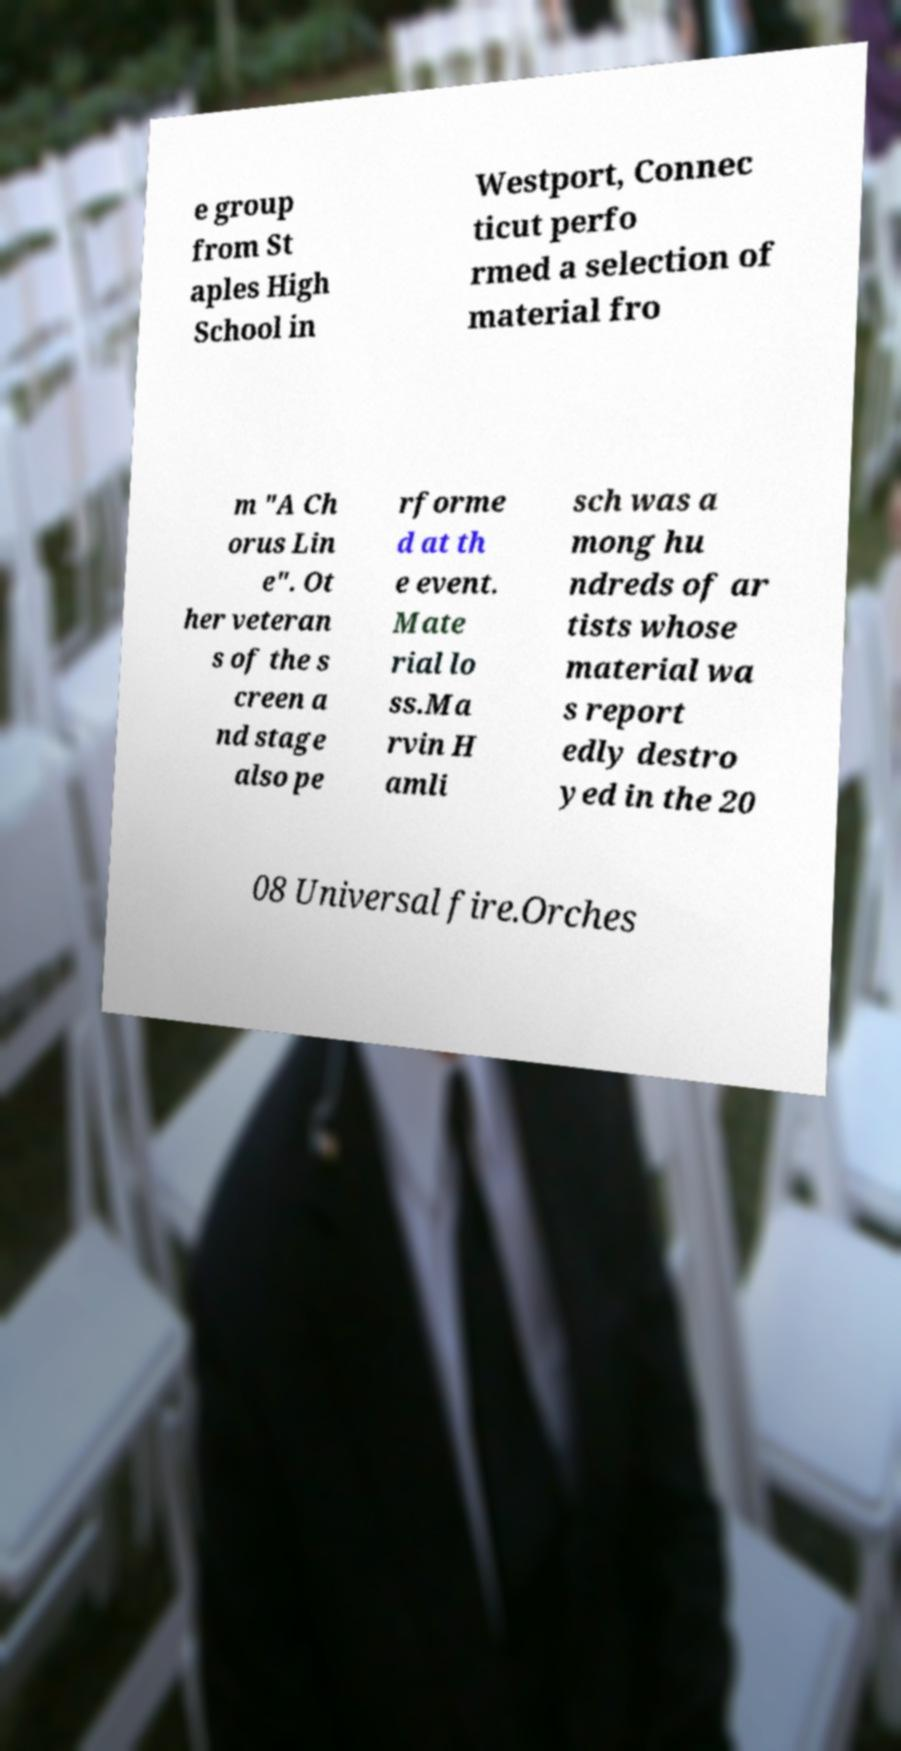Can you read and provide the text displayed in the image?This photo seems to have some interesting text. Can you extract and type it out for me? e group from St aples High School in Westport, Connec ticut perfo rmed a selection of material fro m "A Ch orus Lin e". Ot her veteran s of the s creen a nd stage also pe rforme d at th e event. Mate rial lo ss.Ma rvin H amli sch was a mong hu ndreds of ar tists whose material wa s report edly destro yed in the 20 08 Universal fire.Orches 